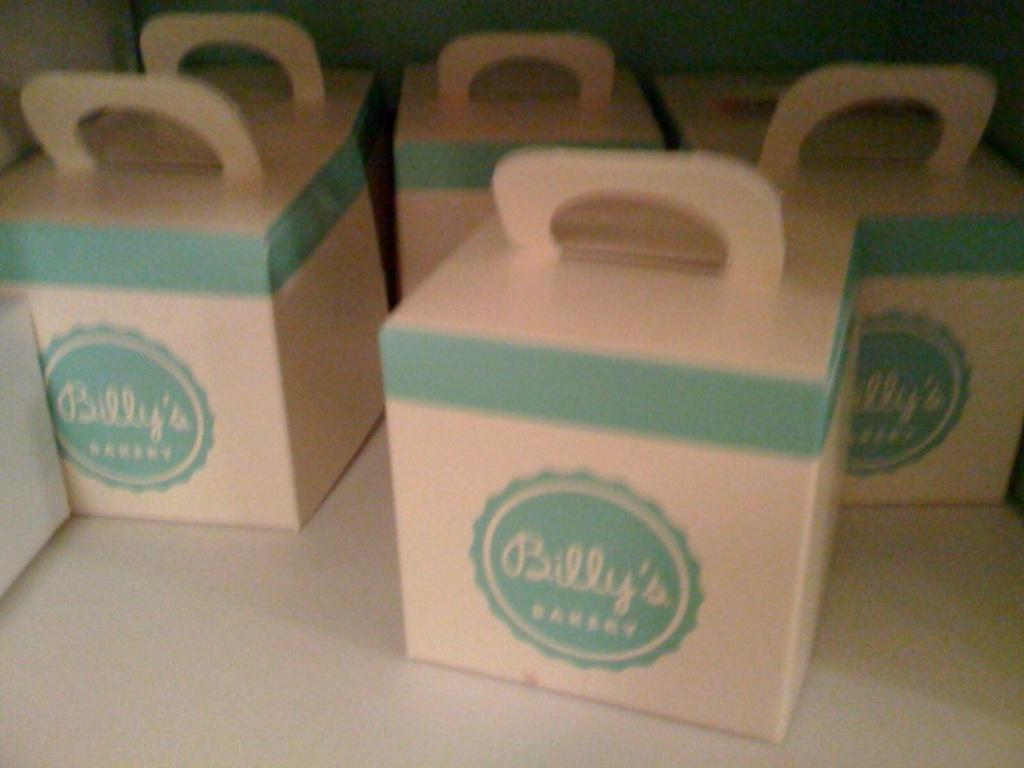<image>
Share a concise interpretation of the image provided. Containers from Billy's Bakery sitting by each other. 